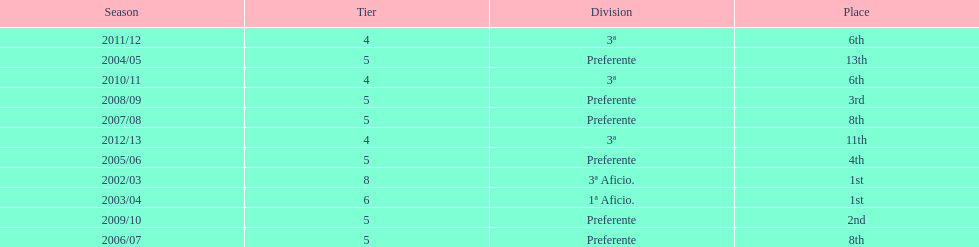In what year did the team achieve the same place as 2010/11? 2011/12. 